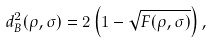<formula> <loc_0><loc_0><loc_500><loc_500>d ^ { 2 } _ { B } ( \rho , \sigma ) = 2 \left ( 1 - \sqrt { F ( \rho , \sigma ) } \right ) ,</formula> 